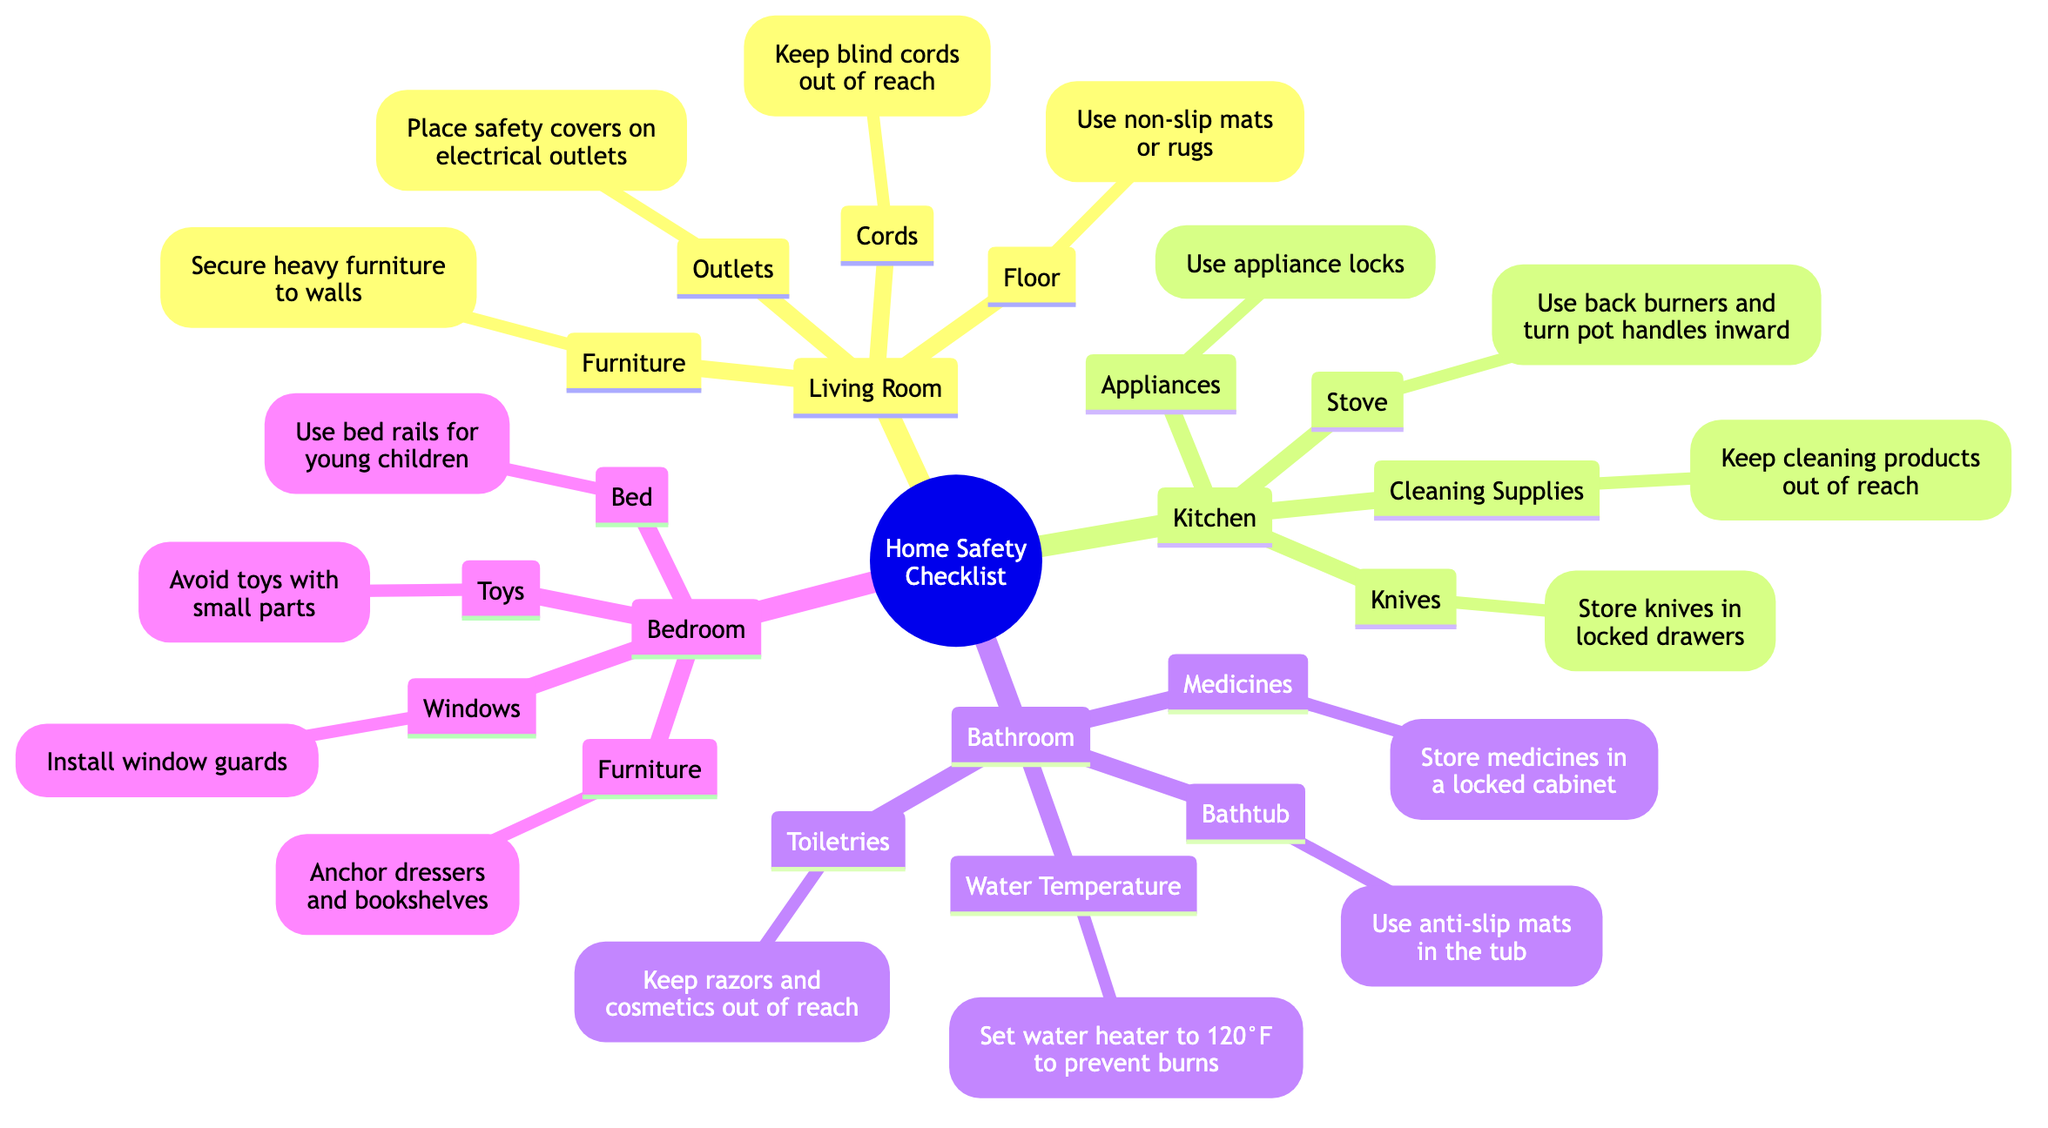What safety measure should be taken with blind cords in the living room? The diagram emphasizes keeping blind cords out of reach to prevent children from getting tangled or injured, ensuring a safer environment in the living room.
Answer: Keep blind cords out of reach How many safety measures are listed for the kitchen? By counting the nodes under the kitchen section in the diagram, there are four safety measures identified: stove, knives, cleaning supplies, and appliances.
Answer: 4 What should be done with medicines in the bathroom? The diagram clearly states that medicines should be stored in a locked cabinet to prevent children from accessing them and potentially harming themselves.
Answer: Store medicines in a locked cabinet How many rooms are included in the home safety checklist? The diagram lists four distinct rooms: Living Room, Kitchen, Bathroom, and Bedroom, which all contain their own safety measures.
Answer: 4 What is the recommended water temperature to set for safety? According to the diagram, the water heater should be set to 120°F to prevent burn injuries among children.
Answer: 120°F What should be used to secure heavy furniture in the living room? The diagram advises that heavy furniture should be secured to walls to prevent tipping over and causing injury to children.
Answer: Secure heavy furniture to walls What is one safety measure for window protection in the bedroom? The diagram notes that installing window guards is a necessary measure to prevent children from falling out of windows, enhancing their safety.
Answer: Install window guards What kind of mats should be used in the bathtub? It is recommended to use anti-slip mats in the bathtub according to the safety checklist provided in the diagram to prevent slipping and injuries.
Answer: Use anti-slip mats What action is suggested for storing knives in the kitchen? The diagram suggests that knives should be stored in locked drawers to ensure children cannot easily access them, reducing the risk of accidents.
Answer: Store knives in locked drawers 